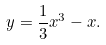<formula> <loc_0><loc_0><loc_500><loc_500>y = \frac { 1 } { 3 } x ^ { 3 } - x .</formula> 